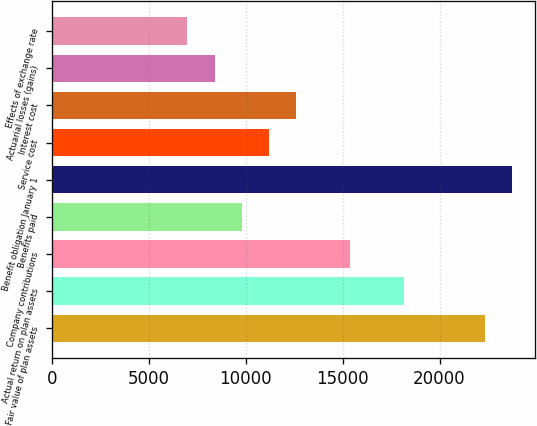<chart> <loc_0><loc_0><loc_500><loc_500><bar_chart><fcel>Fair value of plan assets<fcel>Actual return on plan assets<fcel>Company contributions<fcel>Benefits paid<fcel>Benefit obligation January 1<fcel>Service cost<fcel>Interest cost<fcel>Actuarial losses (gains)<fcel>Effects of exchange rate<nl><fcel>22364.2<fcel>18171.1<fcel>15375.7<fcel>9784.9<fcel>23761.9<fcel>11182.6<fcel>12580.3<fcel>8387.2<fcel>6989.5<nl></chart> 